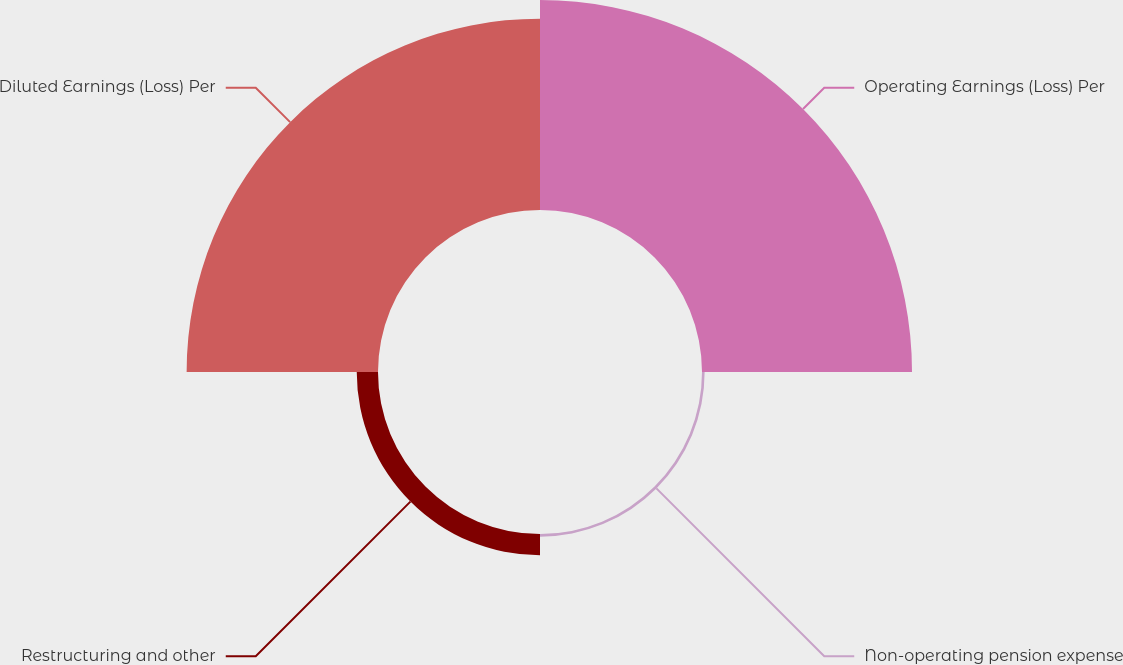<chart> <loc_0><loc_0><loc_500><loc_500><pie_chart><fcel>Operating Earnings (Loss) Per<fcel>Non-operating pension expense<fcel>Restructuring and other<fcel>Diluted Earnings (Loss) Per<nl><fcel>49.38%<fcel>0.62%<fcel>5.0%<fcel>45.0%<nl></chart> 